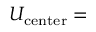<formula> <loc_0><loc_0><loc_500><loc_500>U _ { c e n t e r } =</formula> 